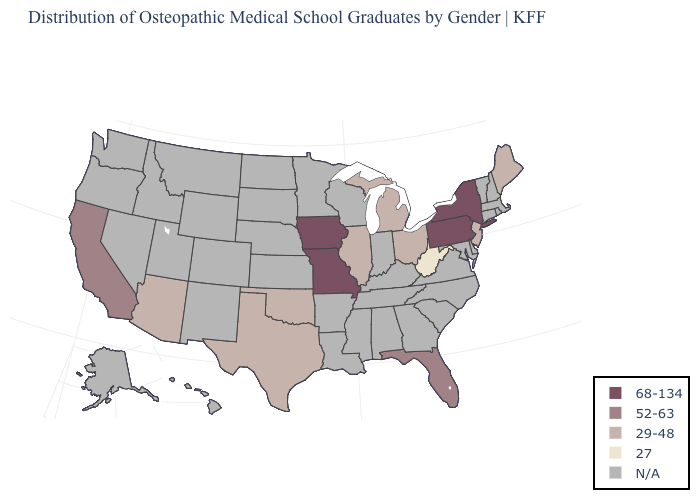Name the states that have a value in the range 29-48?
Give a very brief answer. Arizona, Illinois, Maine, Michigan, New Jersey, Ohio, Oklahoma, Texas. Name the states that have a value in the range 27?
Keep it brief. West Virginia. What is the value of Texas?
Quick response, please. 29-48. Does Texas have the highest value in the South?
Write a very short answer. No. What is the value of Tennessee?
Short answer required. N/A. Among the states that border Oklahoma , which have the highest value?
Be succinct. Missouri. Which states have the lowest value in the Northeast?
Write a very short answer. Maine, New Jersey. Does Iowa have the lowest value in the MidWest?
Keep it brief. No. What is the value of South Carolina?
Concise answer only. N/A. What is the highest value in the MidWest ?
Answer briefly. 68-134. Among the states that border Kentucky , does Ohio have the highest value?
Quick response, please. No. Does the first symbol in the legend represent the smallest category?
Quick response, please. No. What is the highest value in states that border Tennessee?
Be succinct. 68-134. 